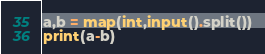<code> <loc_0><loc_0><loc_500><loc_500><_Python_>a,b = map(int,input().split())
print(a-b)</code> 